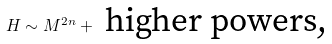Convert formula to latex. <formula><loc_0><loc_0><loc_500><loc_500>H \sim M ^ { 2 n } + \text { higher powers,}</formula> 